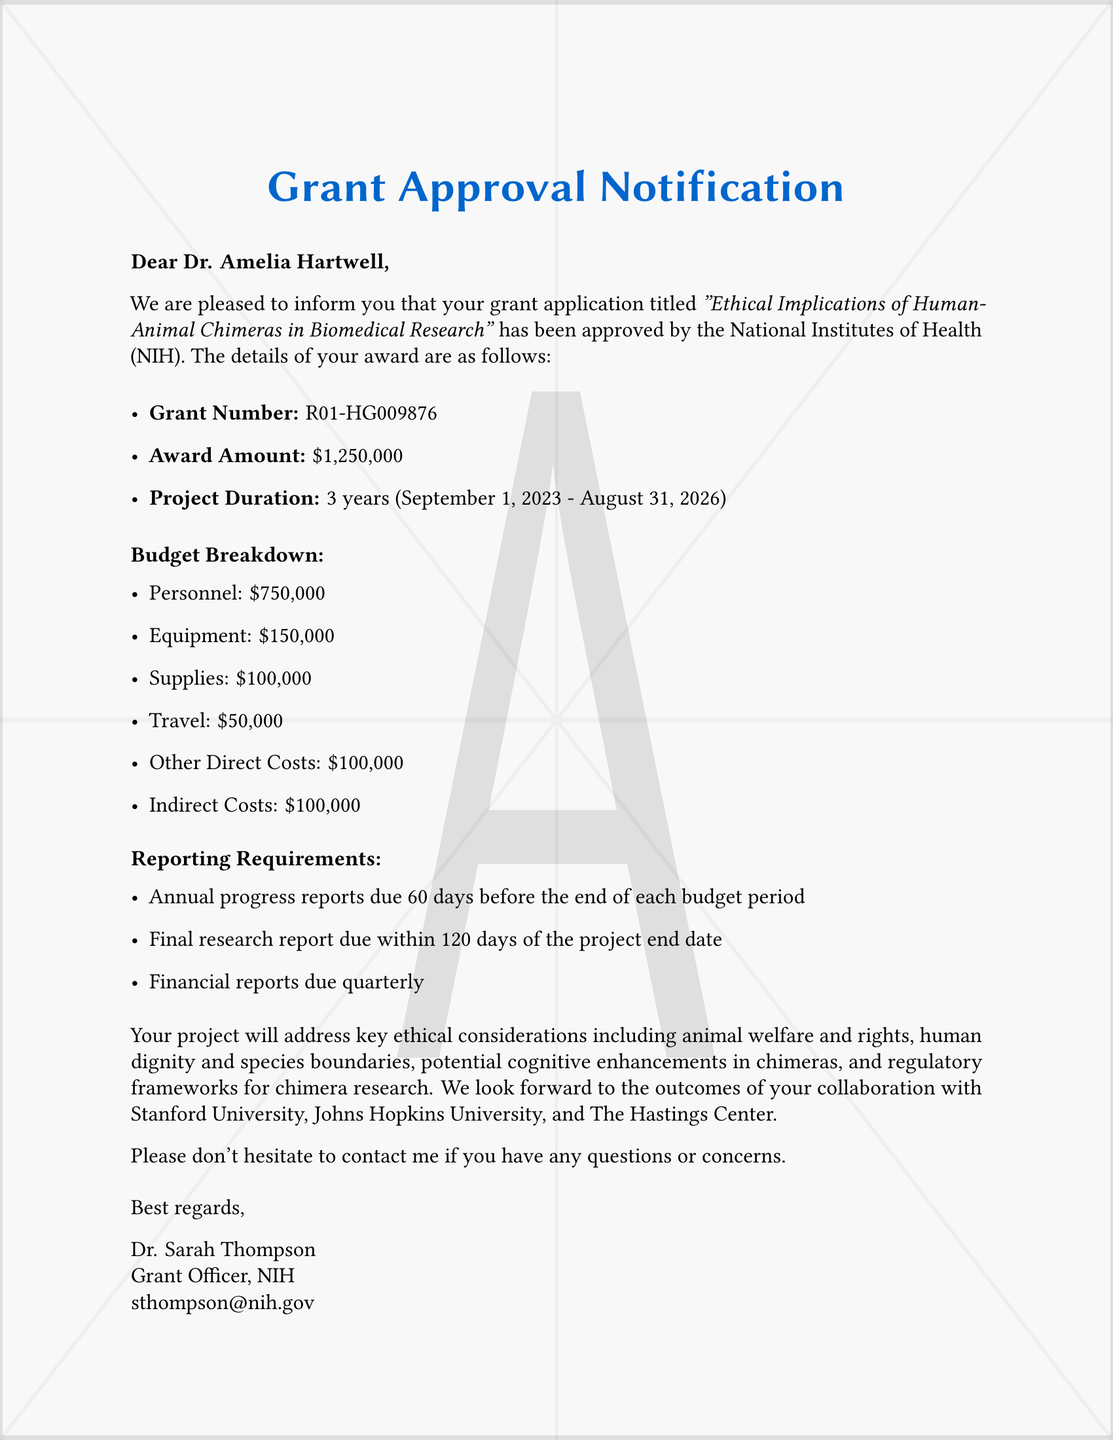What is the grant number? The grant number is specified in the document under the award details.
Answer: R01-HG009876 What is the total award amount? The total award amount is listed in the grant details section.
Answer: $1,250,000 What is the project duration? The project duration is mentioned as the time frame for the grant's effectiveness.
Answer: 3 years When is the final research report due? The due date for the final research report is specified in the reporting requirements.
Answer: within 120 days of the project end date Which institution collaborates on this research? The document lists collaborating institutions involved in the research project.
Answer: Stanford University, Johns Hopkins University, The Hastings Center What are the indirect costs? Indirect costs are part of the budget breakdown provided in the document.
Answer: $100,000 What is one key ethical consideration mentioned? The document outlines several ethical considerations addressed in the project.
Answer: Animal welfare and rights Who is the grant officer? The grant officer's name is mentioned at the end of the notification.
Answer: Dr. Sarah Thompson 